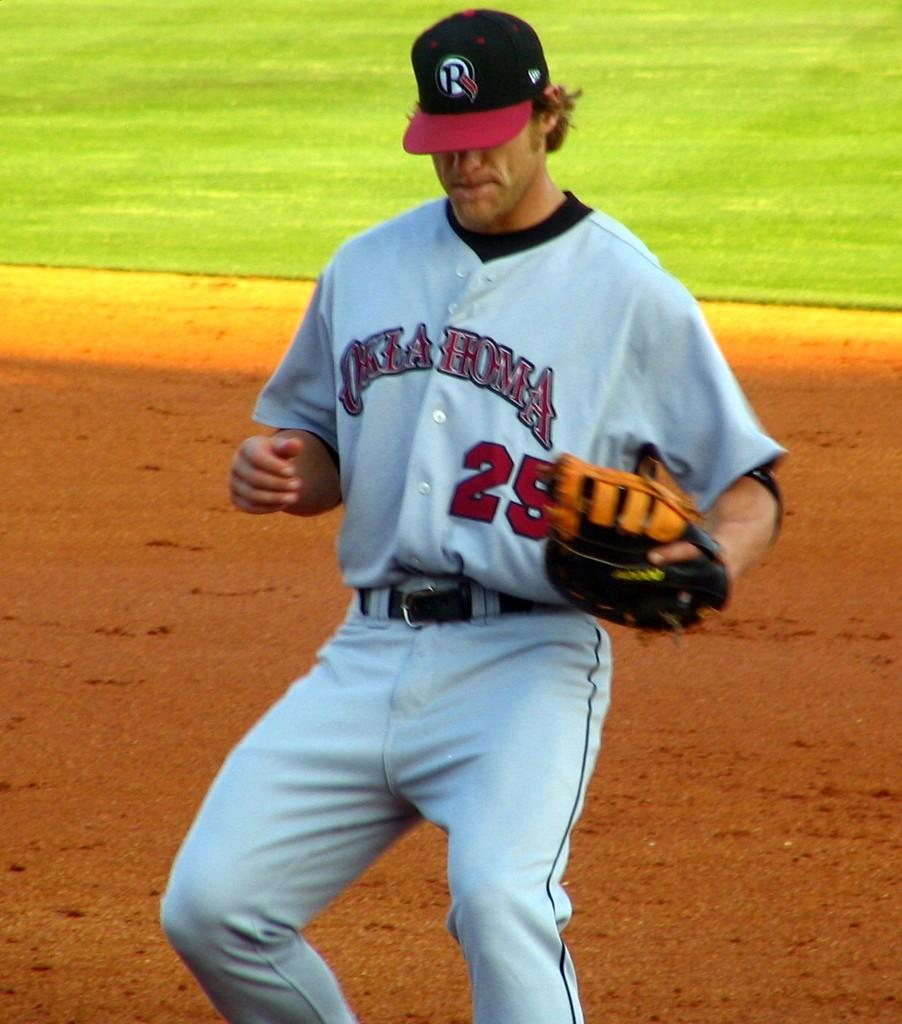<image>
Summarize the visual content of the image. A baseball player wears an Oklahoma uniform with the number 25 on the front. 